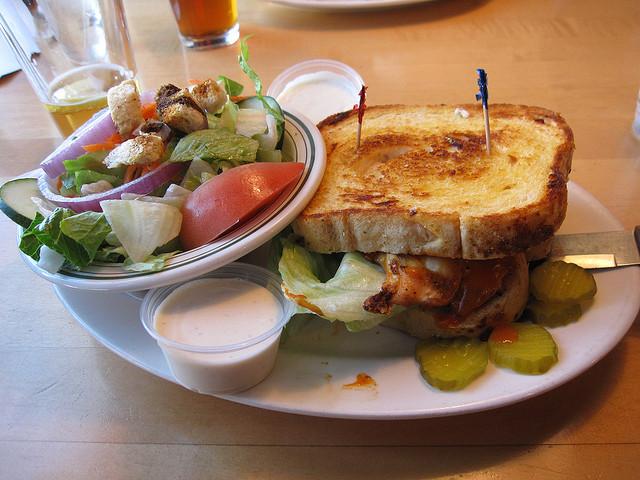What is the red fruit on the white bowl?
Be succinct. Tomato. How many pickles are there?
Quick response, please. 3. What is on the burger?
Give a very brief answer. Lettuce. What beverage is in the cups?
Keep it brief. Beer. What brand of beer is on the table?
Be succinct. Bud. What utensil is partially visible in this image?
Short answer required. Knife. What kind of bread is that?
Answer briefly. Toast. Is the bread toasted?
Answer briefly. Yes. What kind of side came with the sandwich?
Be succinct. Salad. What is on the plate next to the sandwich?
Answer briefly. Salad. Is this breakfast?
Write a very short answer. No. Is the sandwich cut in half?
Give a very brief answer. No. 